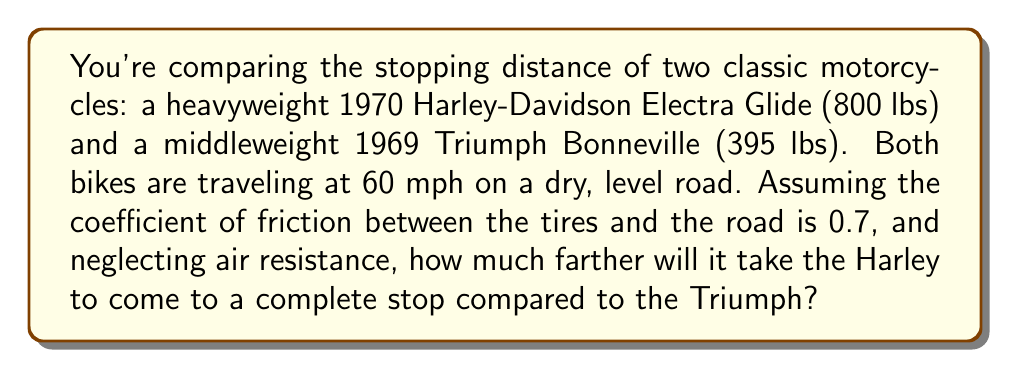Can you solve this math problem? To solve this problem, we'll use the formula for stopping distance based on initial velocity, coefficient of friction, and acceleration due to gravity. Then, we'll compare the results for both motorcycles.

1. The formula for stopping distance is:
   $$d = \frac{v^2}{2\mu g}$$
   Where:
   $d$ = stopping distance
   $v$ = initial velocity
   $\mu$ = coefficient of friction
   $g$ = acceleration due to gravity (9.8 m/s²)

2. Convert 60 mph to m/s:
   $$60 \text{ mph} \times \frac{1609 \text{ m}}{3600 \text{ s}} = 26.82 \text{ m/s}$$

3. For both motorcycles:
   $v = 26.82 \text{ m/s}$
   $\mu = 0.7$
   $g = 9.8 \text{ m/s}^2$

4. Calculate stopping distance for the Harley-Davidson:
   $$d_H = \frac{(26.82 \text{ m/s})^2}{2 \times 0.7 \times 9.8 \text{ m/s}^2} = 52.16 \text{ m}$$

5. Calculate stopping distance for the Triumph:
   $$d_T = \frac{(26.82 \text{ m/s})^2}{2 \times 0.7 \times 9.8 \text{ m/s}^2} = 52.16 \text{ m}$$

6. Calculate the difference in stopping distance:
   $$\Delta d = d_H - d_T = 52.16 \text{ m} - 52.16 \text{ m} = 0 \text{ m}$$

Interestingly, the weight of the motorcycle doesn't affect the stopping distance in this idealized scenario. This is because the increased mass of the heavier motorcycle is offset by the increased normal force, which leads to a proportionally higher friction force. In reality, factors such as tire compound, brake performance, and weight distribution would cause slight differences in stopping distance.
Answer: The Harley-Davidson Electra Glide will stop in the same distance as the Triumph Bonneville under these idealized conditions. The difference in stopping distance is 0 meters. 